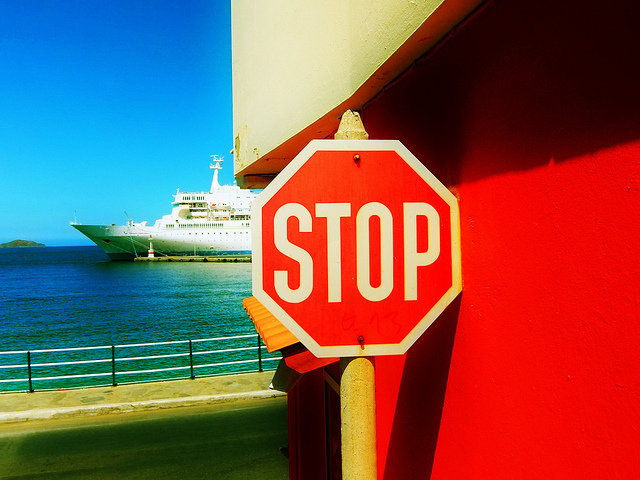How many stop signs are visible? 1 